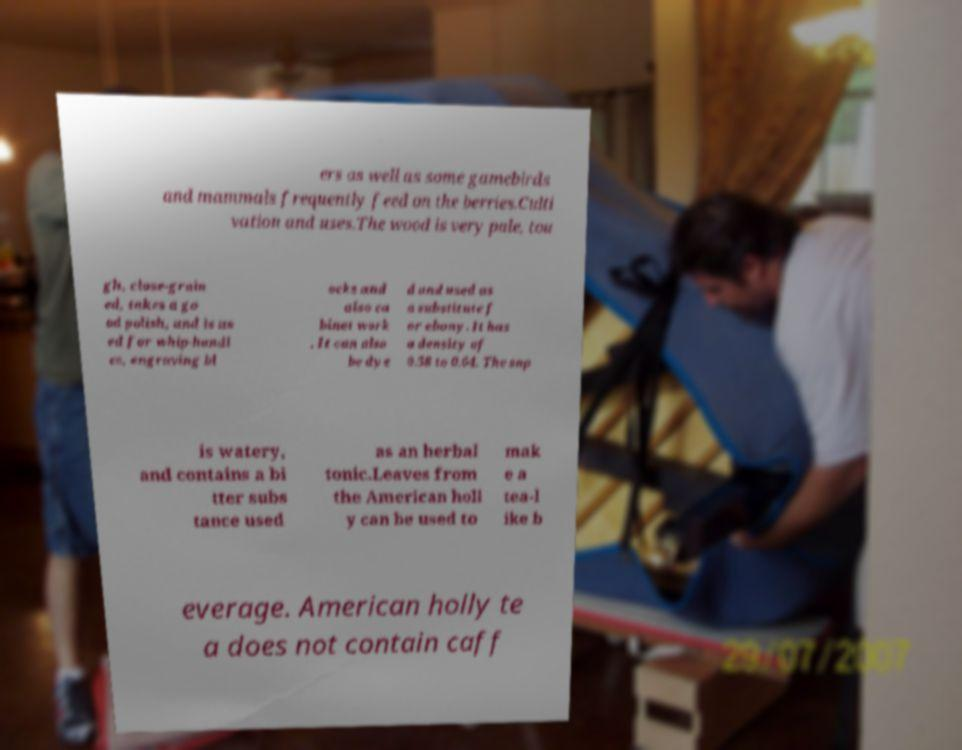For documentation purposes, I need the text within this image transcribed. Could you provide that? ers as well as some gamebirds and mammals frequently feed on the berries.Culti vation and uses.The wood is very pale, tou gh, close-grain ed, takes a go od polish, and is us ed for whip-handl es, engraving bl ocks and also ca binet work . It can also be dye d and used as a substitute f or ebony. It has a density of 0.58 to 0.64. The sap is watery, and contains a bi tter subs tance used as an herbal tonic.Leaves from the American holl y can be used to mak e a tea-l ike b everage. American holly te a does not contain caff 